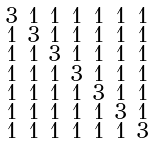Convert formula to latex. <formula><loc_0><loc_0><loc_500><loc_500>\begin{smallmatrix} 3 & 1 & 1 & 1 & 1 & 1 & 1 \\ 1 & 3 & 1 & 1 & 1 & 1 & 1 \\ 1 & 1 & 3 & 1 & 1 & 1 & 1 \\ 1 & 1 & 1 & 3 & 1 & 1 & 1 \\ 1 & 1 & 1 & 1 & 3 & 1 & 1 \\ 1 & 1 & 1 & 1 & 1 & 3 & 1 \\ 1 & 1 & 1 & 1 & 1 & 1 & 3 \end{smallmatrix}</formula> 